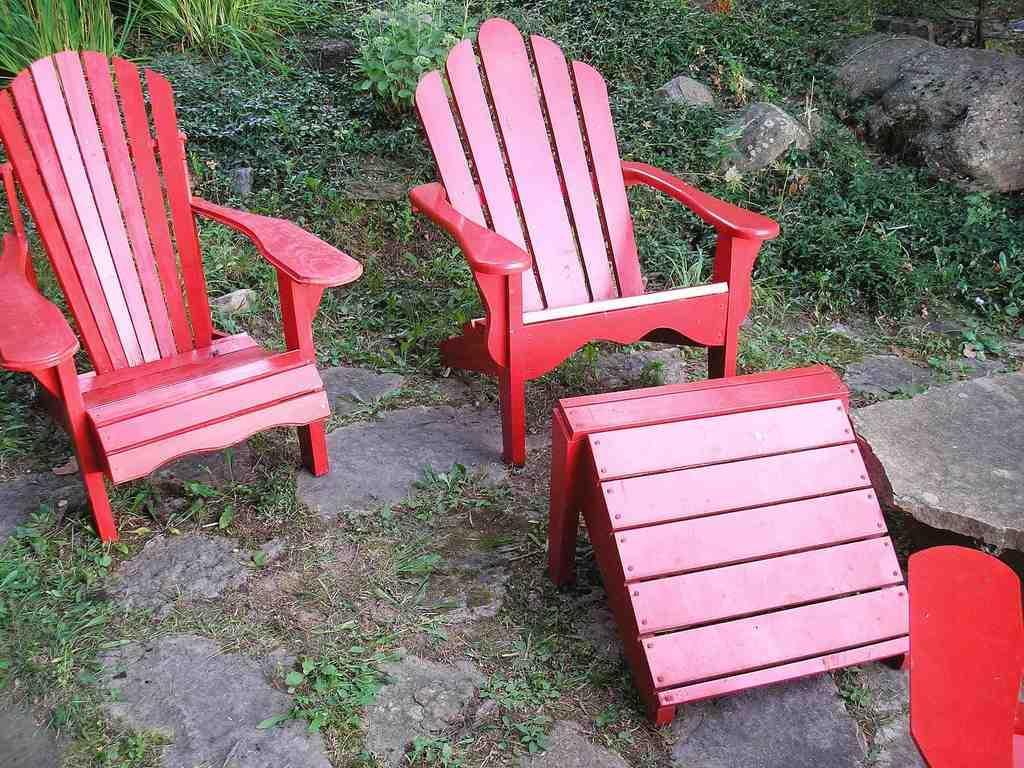Please provide a concise description of this image. In the image there are chairs and also there is a red color object. On the ground there is grass. And also there are small plants, stones and rocks in the background. 